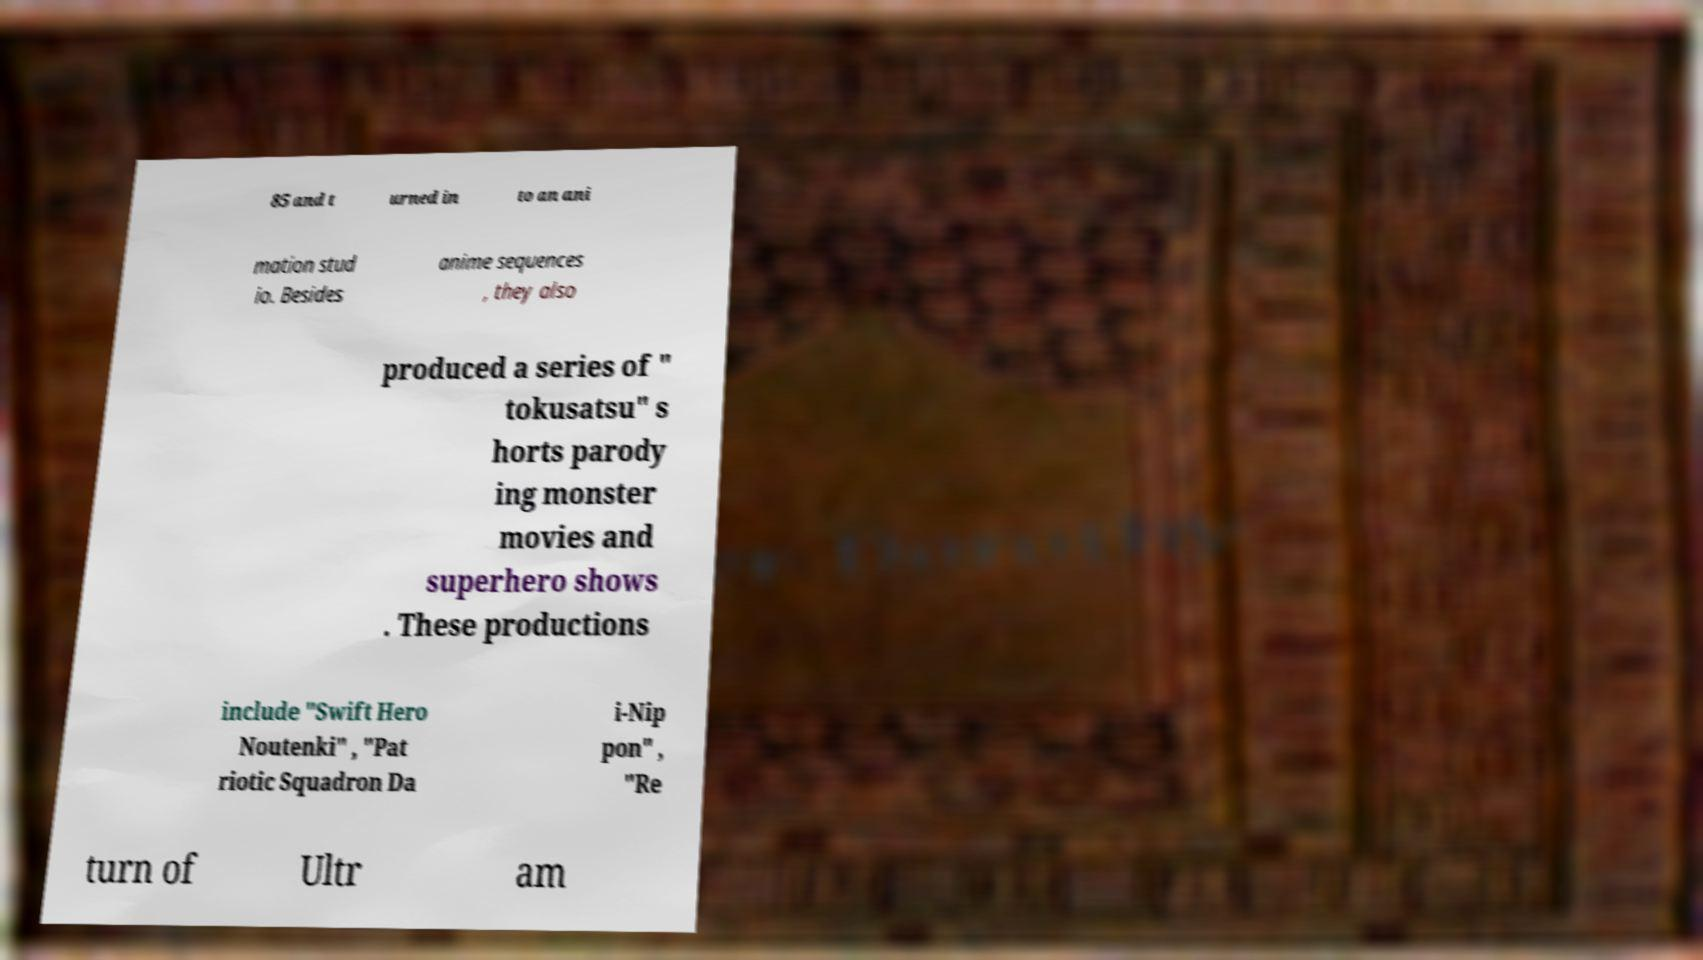Can you read and provide the text displayed in the image?This photo seems to have some interesting text. Can you extract and type it out for me? 85 and t urned in to an ani mation stud io. Besides anime sequences , they also produced a series of " tokusatsu" s horts parody ing monster movies and superhero shows . These productions include "Swift Hero Noutenki" , "Pat riotic Squadron Da i-Nip pon" , "Re turn of Ultr am 